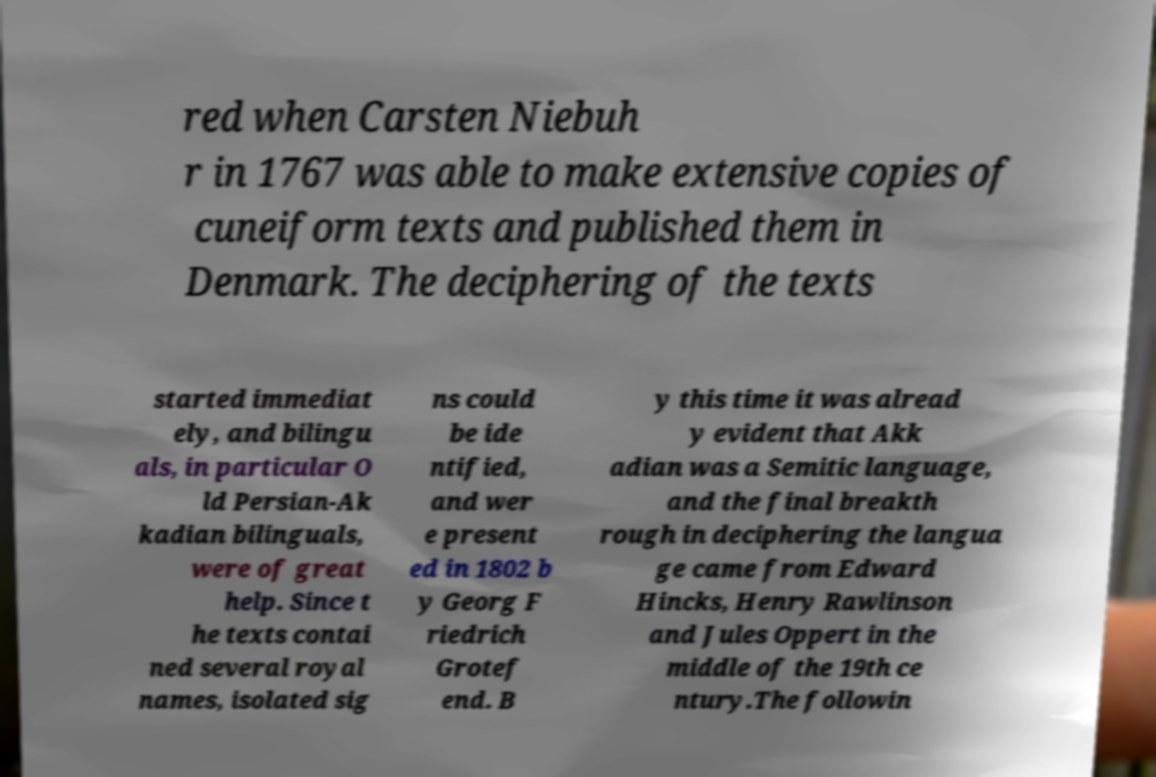For documentation purposes, I need the text within this image transcribed. Could you provide that? red when Carsten Niebuh r in 1767 was able to make extensive copies of cuneiform texts and published them in Denmark. The deciphering of the texts started immediat ely, and bilingu als, in particular O ld Persian-Ak kadian bilinguals, were of great help. Since t he texts contai ned several royal names, isolated sig ns could be ide ntified, and wer e present ed in 1802 b y Georg F riedrich Grotef end. B y this time it was alread y evident that Akk adian was a Semitic language, and the final breakth rough in deciphering the langua ge came from Edward Hincks, Henry Rawlinson and Jules Oppert in the middle of the 19th ce ntury.The followin 